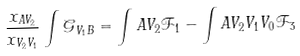<formula> <loc_0><loc_0><loc_500><loc_500>\frac { x _ { A V _ { 2 } } } { x _ { V _ { 2 } V _ { 1 } } } \int \mathcal { G } _ { V _ { 1 } B } = \int A V _ { 2 } \mathcal { F } _ { 1 } - \int A V _ { 2 } V _ { 1 } V _ { 0 } \mathcal { F } _ { 3 }</formula> 